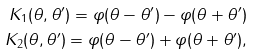Convert formula to latex. <formula><loc_0><loc_0><loc_500><loc_500>K _ { 1 } ( \theta , \theta ^ { \prime } ) = \varphi ( \theta - \theta ^ { \prime } ) - \varphi ( \theta + \theta ^ { \prime } ) \\ K _ { 2 } ( \theta , \theta ^ { \prime } ) = \varphi ( \theta - \theta ^ { \prime } ) + \varphi ( \theta + \theta ^ { \prime } ) ,</formula> 